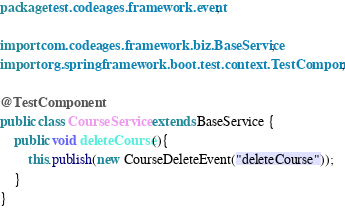<code> <loc_0><loc_0><loc_500><loc_500><_Java_>package test.codeages.framework.event;

import com.codeages.framework.biz.BaseService;
import org.springframework.boot.test.context.TestComponent;

@TestComponent
public class CourseService extends BaseService {
    public void deleteCourse(){
        this.publish(new CourseDeleteEvent("deleteCourse"));
    }
}
</code> 